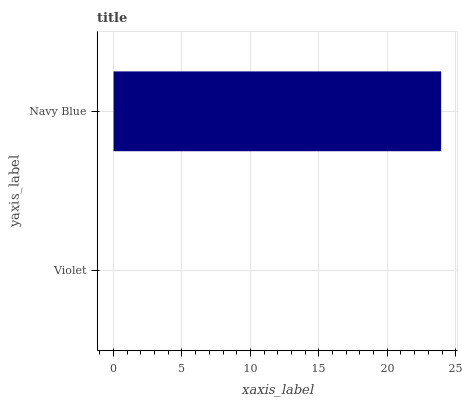Is Violet the minimum?
Answer yes or no. Yes. Is Navy Blue the maximum?
Answer yes or no. Yes. Is Navy Blue the minimum?
Answer yes or no. No. Is Navy Blue greater than Violet?
Answer yes or no. Yes. Is Violet less than Navy Blue?
Answer yes or no. Yes. Is Violet greater than Navy Blue?
Answer yes or no. No. Is Navy Blue less than Violet?
Answer yes or no. No. Is Navy Blue the high median?
Answer yes or no. Yes. Is Violet the low median?
Answer yes or no. Yes. Is Violet the high median?
Answer yes or no. No. Is Navy Blue the low median?
Answer yes or no. No. 